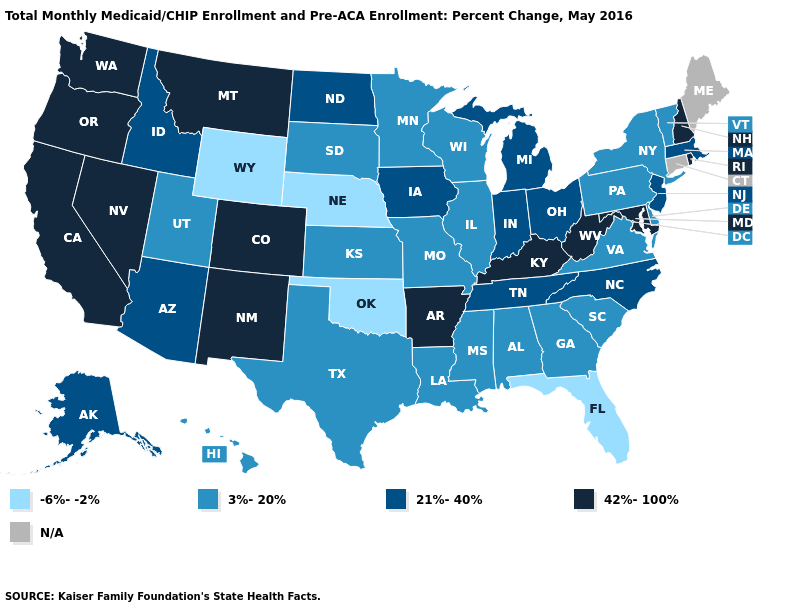Name the states that have a value in the range 3%-20%?
Be succinct. Alabama, Delaware, Georgia, Hawaii, Illinois, Kansas, Louisiana, Minnesota, Mississippi, Missouri, New York, Pennsylvania, South Carolina, South Dakota, Texas, Utah, Vermont, Virginia, Wisconsin. What is the value of New Hampshire?
Keep it brief. 42%-100%. Which states have the lowest value in the South?
Concise answer only. Florida, Oklahoma. Name the states that have a value in the range 21%-40%?
Be succinct. Alaska, Arizona, Idaho, Indiana, Iowa, Massachusetts, Michigan, New Jersey, North Carolina, North Dakota, Ohio, Tennessee. Among the states that border Alabama , which have the highest value?
Give a very brief answer. Tennessee. Name the states that have a value in the range 21%-40%?
Write a very short answer. Alaska, Arizona, Idaho, Indiana, Iowa, Massachusetts, Michigan, New Jersey, North Carolina, North Dakota, Ohio, Tennessee. How many symbols are there in the legend?
Concise answer only. 5. What is the value of Oklahoma?
Concise answer only. -6%--2%. Does the first symbol in the legend represent the smallest category?
Answer briefly. Yes. Which states have the lowest value in the South?
Concise answer only. Florida, Oklahoma. Among the states that border South Carolina , which have the highest value?
Keep it brief. North Carolina. How many symbols are there in the legend?
Write a very short answer. 5. Is the legend a continuous bar?
Short answer required. No. Does South Dakota have the highest value in the USA?
Short answer required. No. Among the states that border Virginia , which have the lowest value?
Keep it brief. North Carolina, Tennessee. 